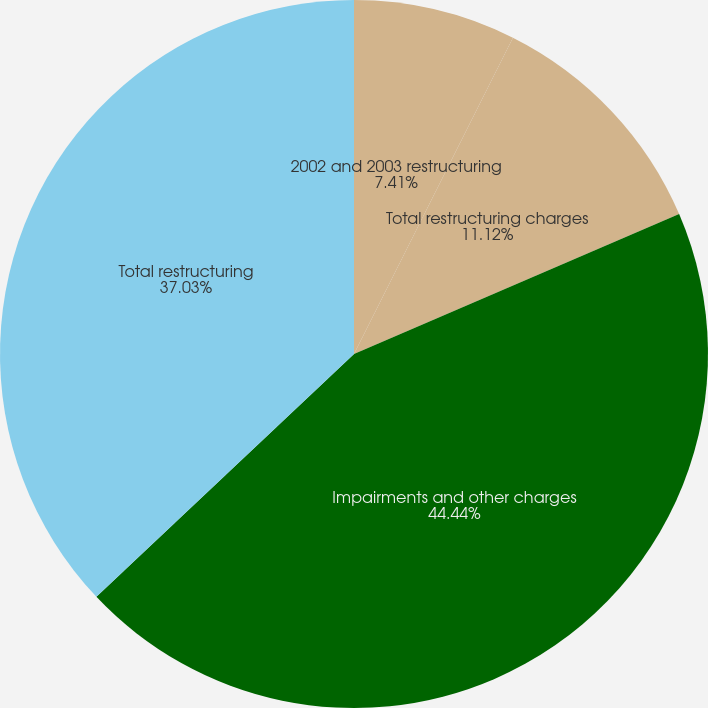Convert chart. <chart><loc_0><loc_0><loc_500><loc_500><pie_chart><fcel>2002 and 2003 restructuring<fcel>Total restructuring charges<fcel>Impairments and other charges<fcel>Total restructuring<nl><fcel>7.41%<fcel>11.12%<fcel>44.44%<fcel>37.03%<nl></chart> 